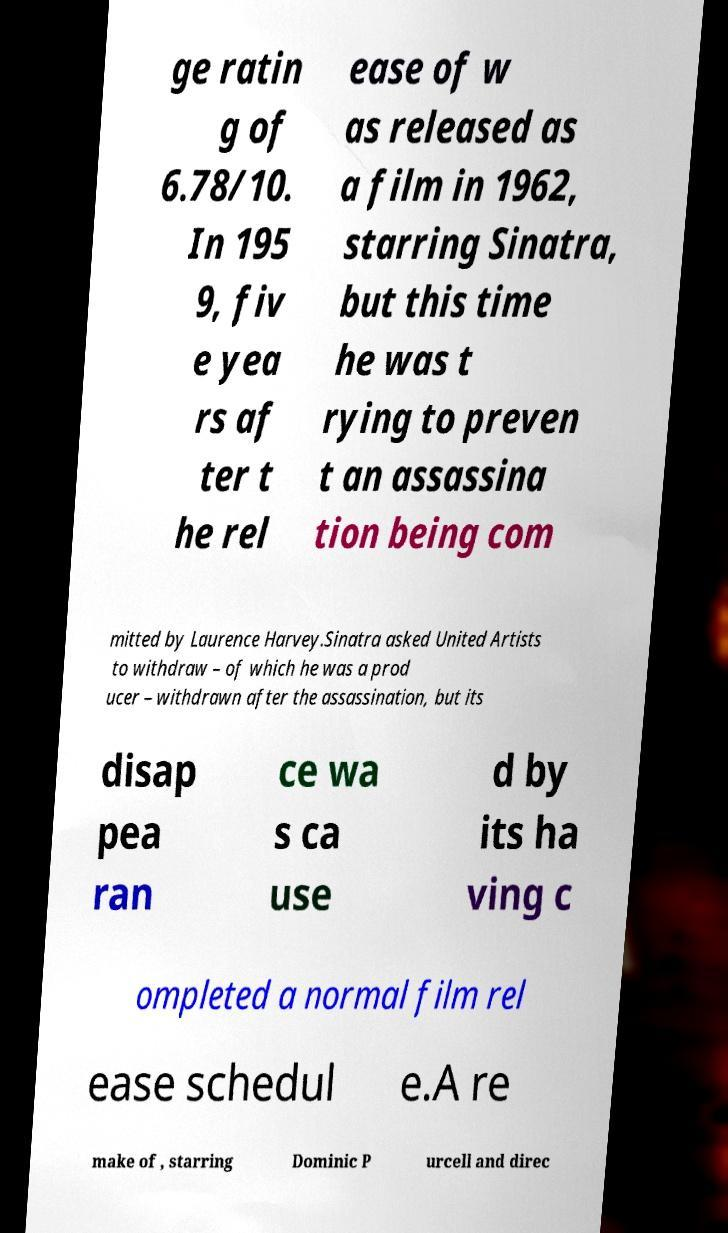I need the written content from this picture converted into text. Can you do that? ge ratin g of 6.78/10. In 195 9, fiv e yea rs af ter t he rel ease of w as released as a film in 1962, starring Sinatra, but this time he was t rying to preven t an assassina tion being com mitted by Laurence Harvey.Sinatra asked United Artists to withdraw – of which he was a prod ucer – withdrawn after the assassination, but its disap pea ran ce wa s ca use d by its ha ving c ompleted a normal film rel ease schedul e.A re make of , starring Dominic P urcell and direc 